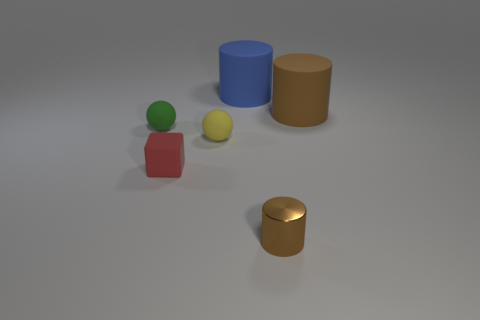Is there any indication of the scale or size of these objects? Without any standard reference object or known environment, it's challenging to determine the exact scale or size of the objects. However, the shadows relative to each object imply that the lighting is consistent, suggesting that all objects are comparable in size and presumably small enough to be placed on a tabletop. 